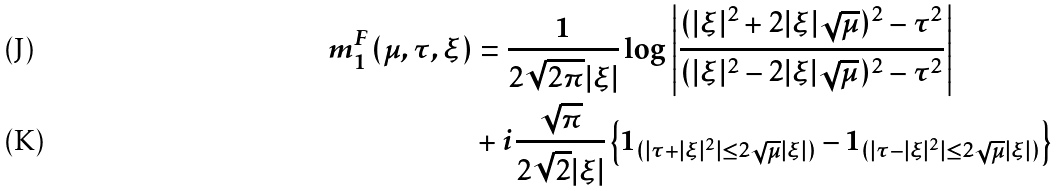<formula> <loc_0><loc_0><loc_500><loc_500>m _ { 1 } ^ { F } ( \mu , \tau , \xi ) & = \frac { 1 } { 2 \sqrt { 2 \pi } | \xi | } \log \left | \frac { ( | \xi | ^ { 2 } + 2 | \xi | \sqrt { \mu } ) ^ { 2 } - \tau ^ { 2 } } { ( | \xi | ^ { 2 } - 2 | \xi | \sqrt { \mu } ) ^ { 2 } - \tau ^ { 2 } } \right | \\ & + i \frac { \sqrt { \pi } } { 2 \sqrt { 2 } | \xi | } \left \{ 1 _ { ( | \tau + | \xi | ^ { 2 } | \leq 2 \sqrt { \mu } | \xi | ) } - 1 _ { ( | \tau - | \xi | ^ { 2 } | \leq 2 \sqrt { \mu } | \xi | ) } \right \}</formula> 